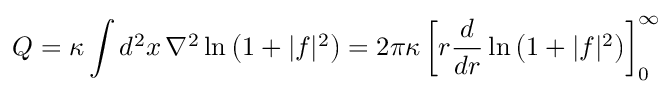Convert formula to latex. <formula><loc_0><loc_0><loc_500><loc_500>Q = \kappa \int d ^ { 2 } x \, \nabla ^ { 2 } \ln \left ( 1 + | f | ^ { 2 } \right ) = 2 \pi \kappa \left [ r { \frac { d } { d r } } \ln \left ( 1 + | f | ^ { 2 } \right ) \right ] _ { 0 } ^ { \infty }</formula> 